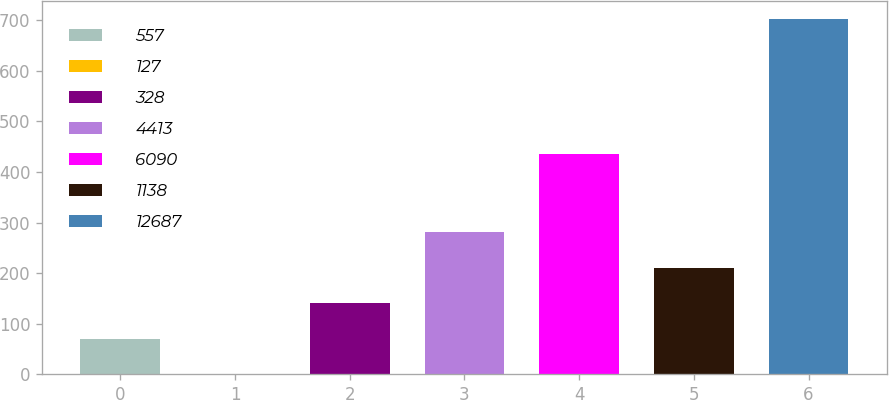<chart> <loc_0><loc_0><loc_500><loc_500><bar_chart><fcel>557<fcel>127<fcel>328<fcel>4413<fcel>6090<fcel>1138<fcel>12687<nl><fcel>70.31<fcel>0.1<fcel>140.52<fcel>280.94<fcel>435.8<fcel>210.73<fcel>702.2<nl></chart> 